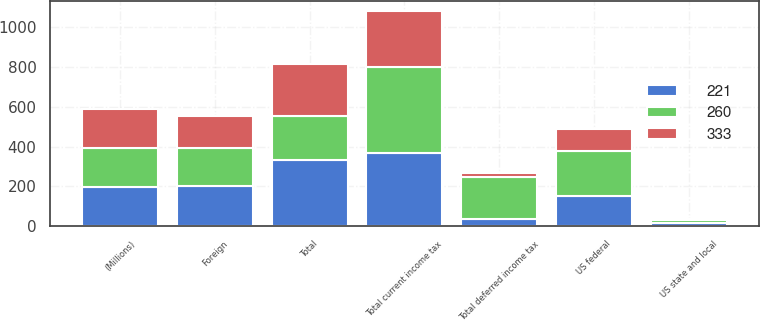Convert chart. <chart><loc_0><loc_0><loc_500><loc_500><stacked_bar_chart><ecel><fcel>(Millions)<fcel>US federal<fcel>US state and local<fcel>Foreign<fcel>Total current income tax<fcel>Total deferred income tax<fcel>Total<nl><fcel>221<fcel>196<fcel>153<fcel>14<fcel>202<fcel>369<fcel>36<fcel>333<nl><fcel>260<fcel>196<fcel>228<fcel>15<fcel>190<fcel>433<fcel>212<fcel>221<nl><fcel>333<fcel>196<fcel>107<fcel>8<fcel>164<fcel>279<fcel>19<fcel>260<nl></chart> 